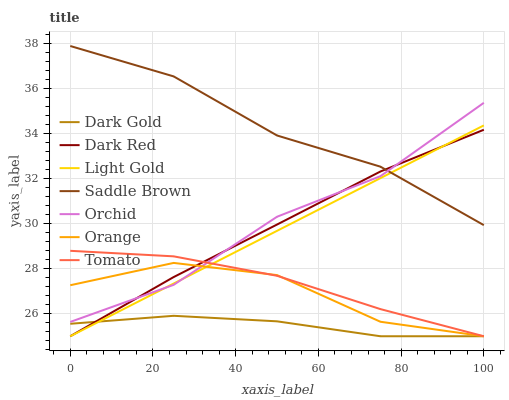Does Dark Gold have the minimum area under the curve?
Answer yes or no. Yes. Does Saddle Brown have the maximum area under the curve?
Answer yes or no. Yes. Does Dark Red have the minimum area under the curve?
Answer yes or no. No. Does Dark Red have the maximum area under the curve?
Answer yes or no. No. Is Light Gold the smoothest?
Answer yes or no. Yes. Is Orange the roughest?
Answer yes or no. Yes. Is Dark Gold the smoothest?
Answer yes or no. No. Is Dark Gold the roughest?
Answer yes or no. No. Does Tomato have the lowest value?
Answer yes or no. Yes. Does Saddle Brown have the lowest value?
Answer yes or no. No. Does Saddle Brown have the highest value?
Answer yes or no. Yes. Does Dark Red have the highest value?
Answer yes or no. No. Is Dark Gold less than Orchid?
Answer yes or no. Yes. Is Saddle Brown greater than Tomato?
Answer yes or no. Yes. Does Tomato intersect Orchid?
Answer yes or no. Yes. Is Tomato less than Orchid?
Answer yes or no. No. Is Tomato greater than Orchid?
Answer yes or no. No. Does Dark Gold intersect Orchid?
Answer yes or no. No. 